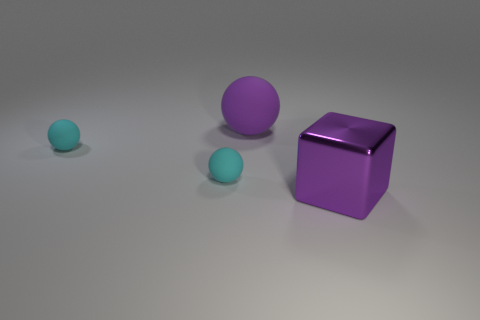Add 3 cyan matte spheres. How many objects exist? 7 Subtract all cyan spheres. How many were subtracted if there are1cyan spheres left? 1 Subtract all cyan balls. How many balls are left? 1 Subtract all large matte balls. How many balls are left? 2 Subtract 0 green cubes. How many objects are left? 4 Subtract all cubes. How many objects are left? 3 Subtract all red cubes. Subtract all red cylinders. How many cubes are left? 1 Subtract all brown cylinders. How many gray blocks are left? 0 Subtract all small cyan matte things. Subtract all big purple metallic objects. How many objects are left? 1 Add 1 large rubber spheres. How many large rubber spheres are left? 2 